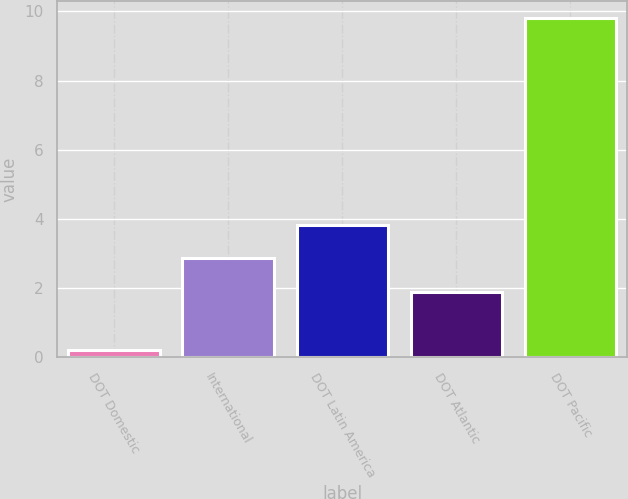<chart> <loc_0><loc_0><loc_500><loc_500><bar_chart><fcel>DOT Domestic<fcel>International<fcel>DOT Latin America<fcel>DOT Atlantic<fcel>DOT Pacific<nl><fcel>0.2<fcel>2.86<fcel>3.82<fcel>1.9<fcel>9.8<nl></chart> 